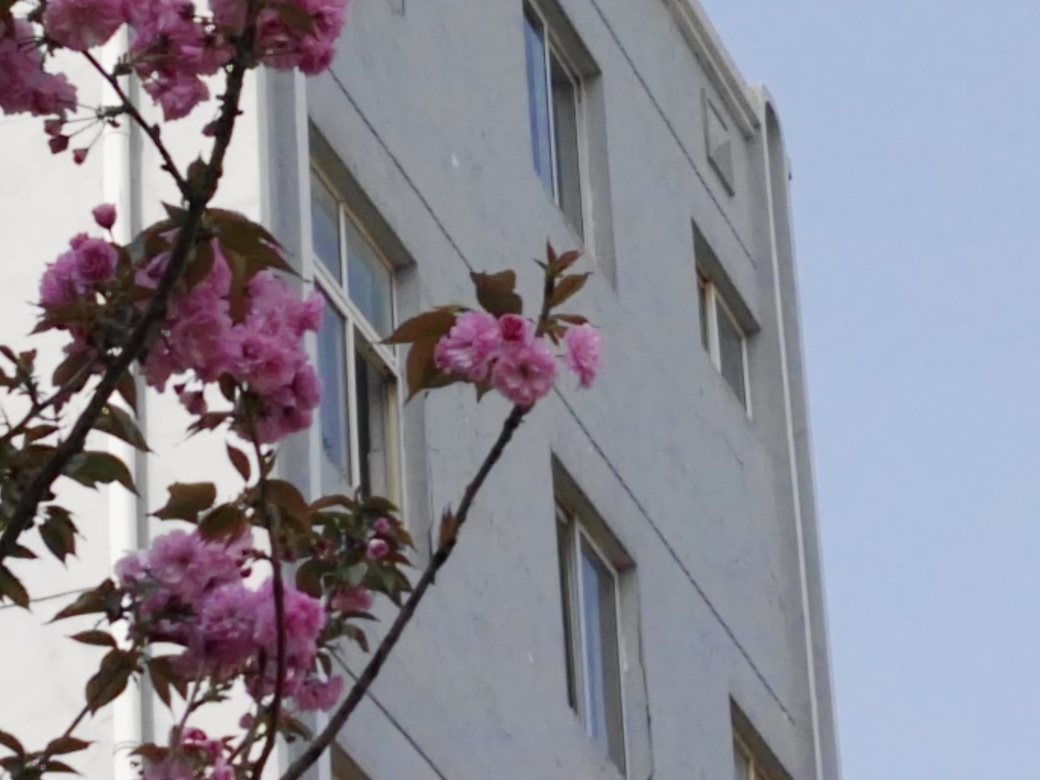What mood does the combination of the flowers and the building evoke? The juxtaposition of the delicate pink blossoms with the stark, unadorned building evokes a mood of contrast between the natural and the man-made. It can represent the resilience of nature in an urban environment, or the fleeting beauty of nature amidst the permanence of the built environment. This scene might illustrate how urban spaces can be softened and made more inviting with the presence of natural elements. 